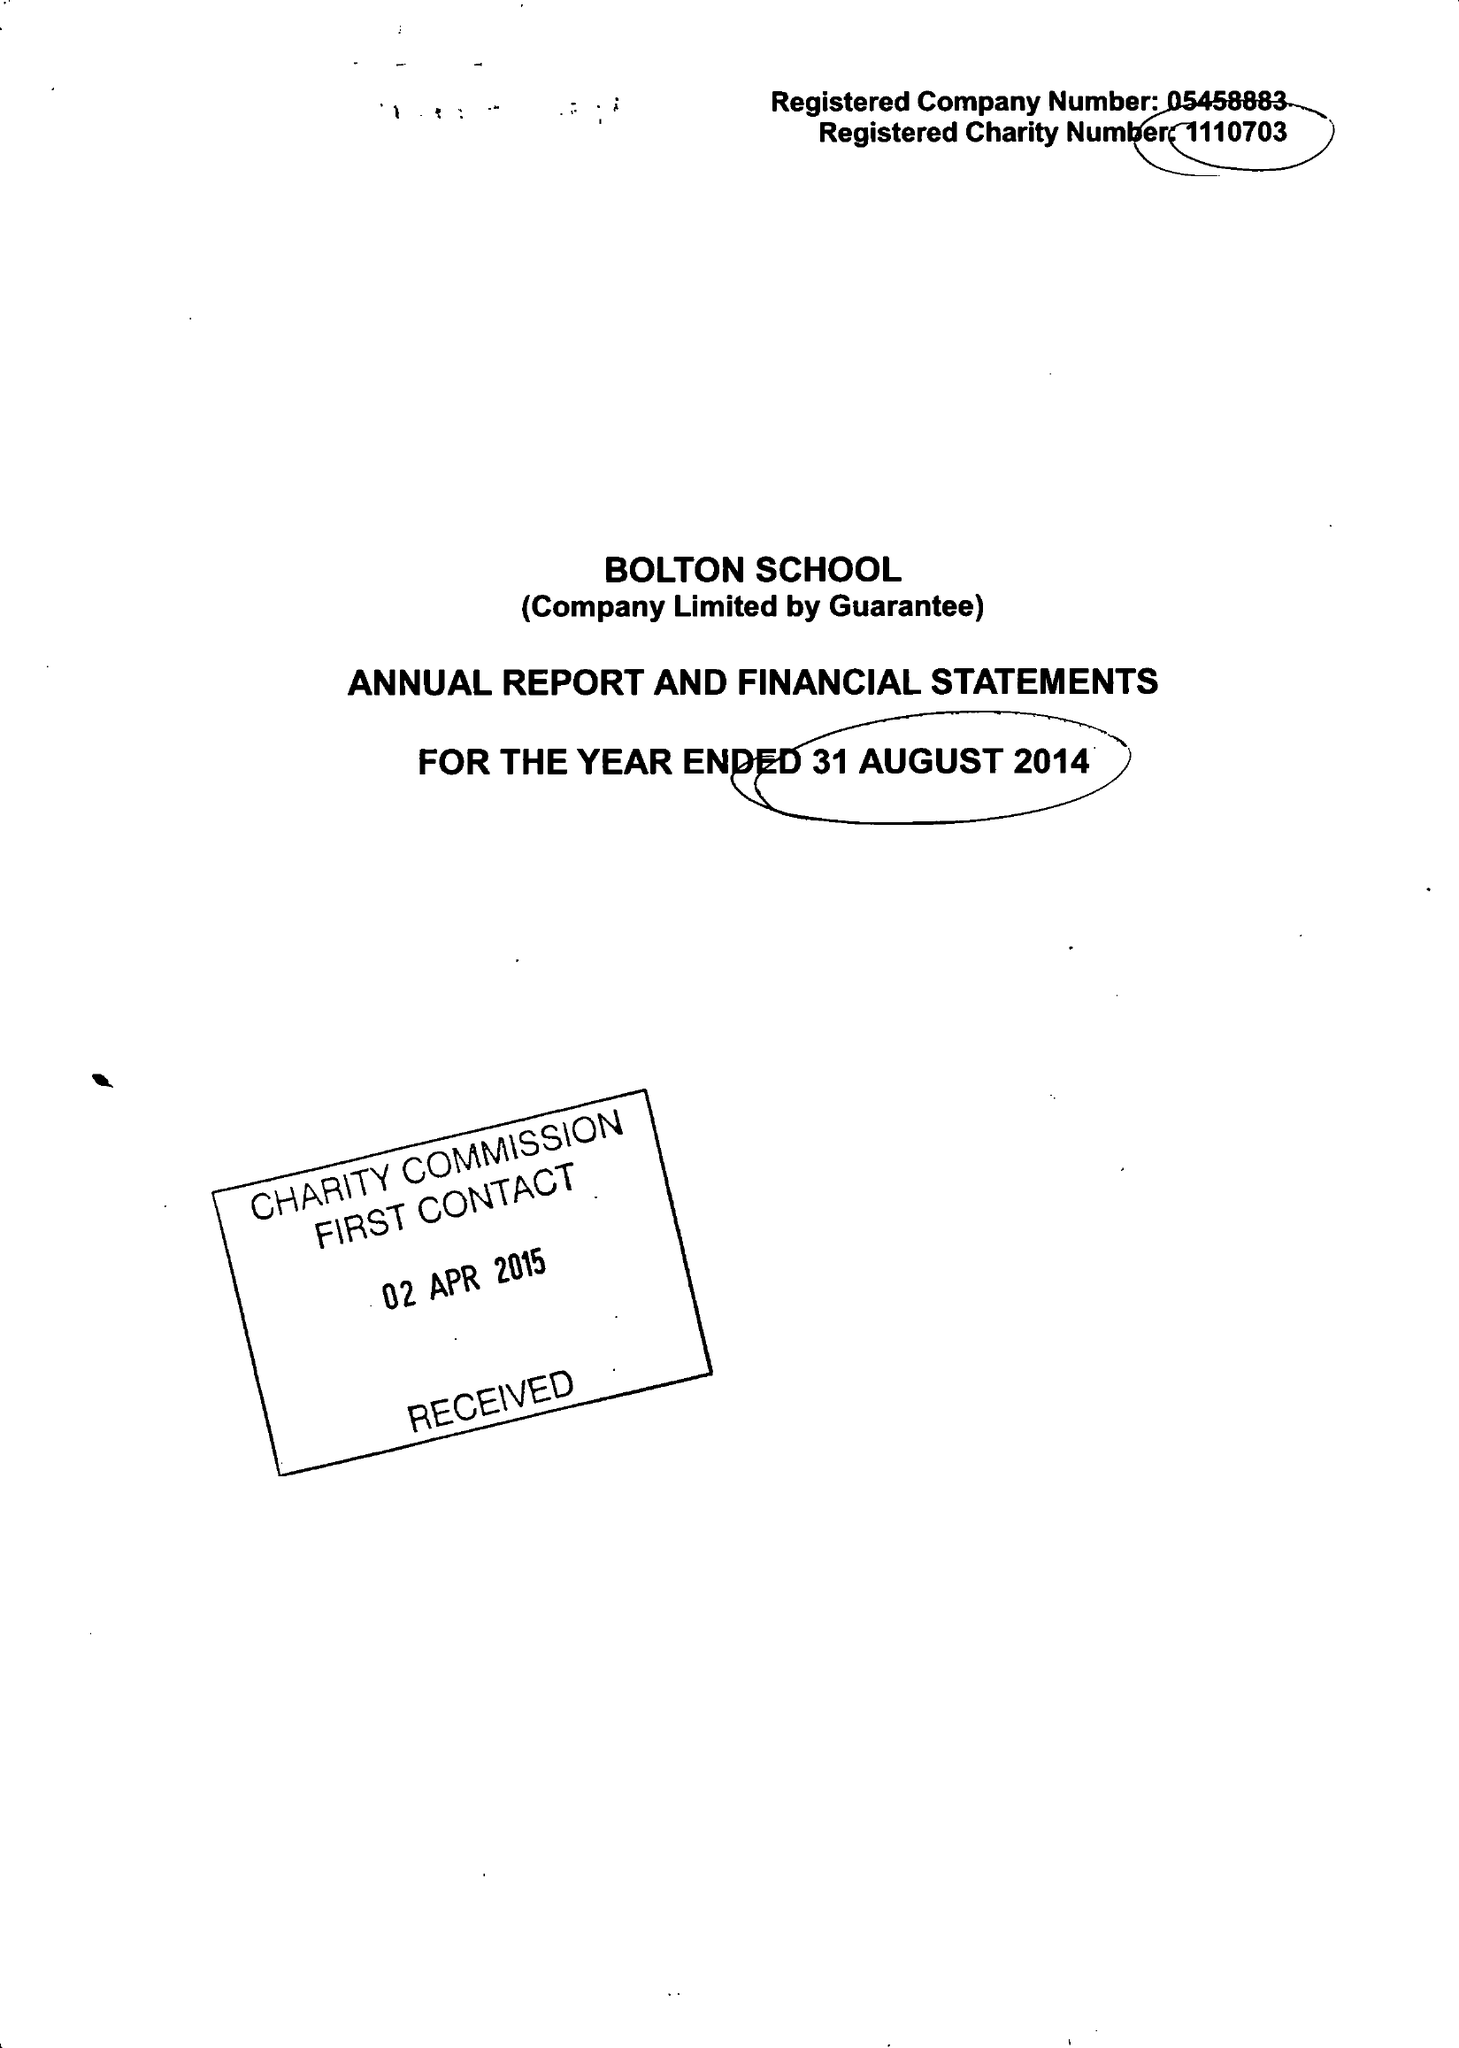What is the value for the charity_number?
Answer the question using a single word or phrase. 1110703 